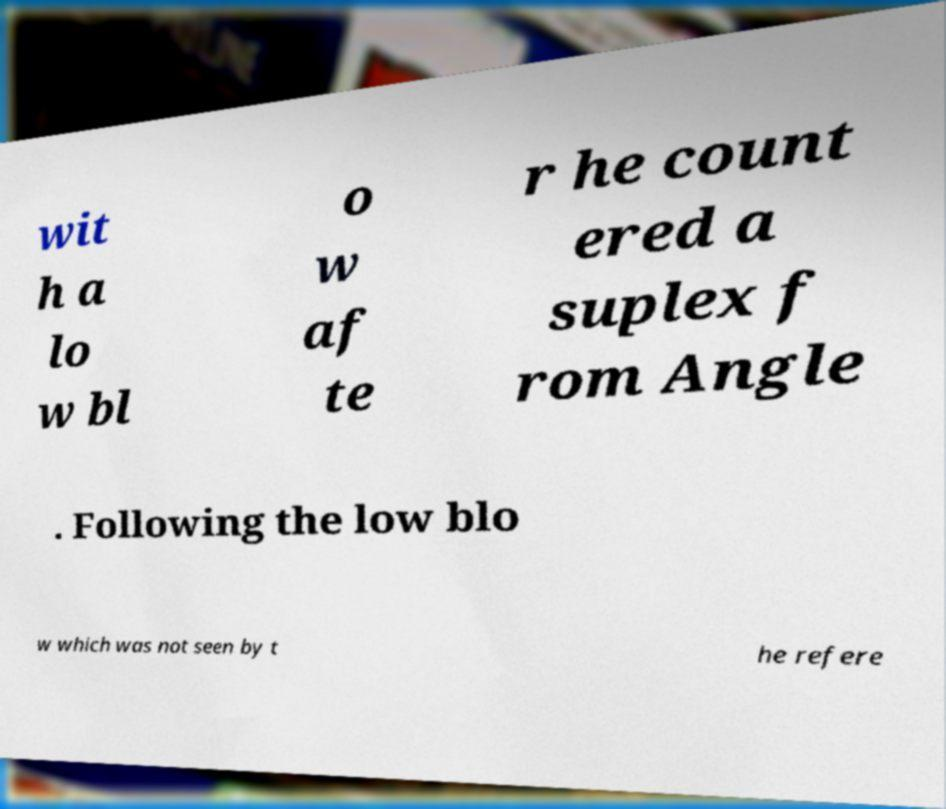There's text embedded in this image that I need extracted. Can you transcribe it verbatim? wit h a lo w bl o w af te r he count ered a suplex f rom Angle . Following the low blo w which was not seen by t he refere 